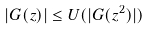<formula> <loc_0><loc_0><loc_500><loc_500>| G ( z ) | \leq U ( | G ( z ^ { 2 } ) | )</formula> 